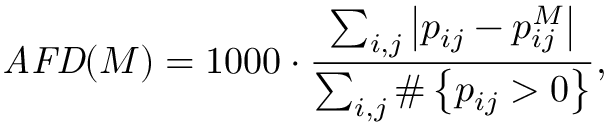<formula> <loc_0><loc_0><loc_500><loc_500>A F D ( M ) = 1 0 0 0 \cdot \frac { \sum _ { i , j } \left | p _ { i j } - p _ { i j } ^ { M } \right | } { \sum _ { i , j } \# \left \{ p _ { i j } > 0 \right \} } ,</formula> 